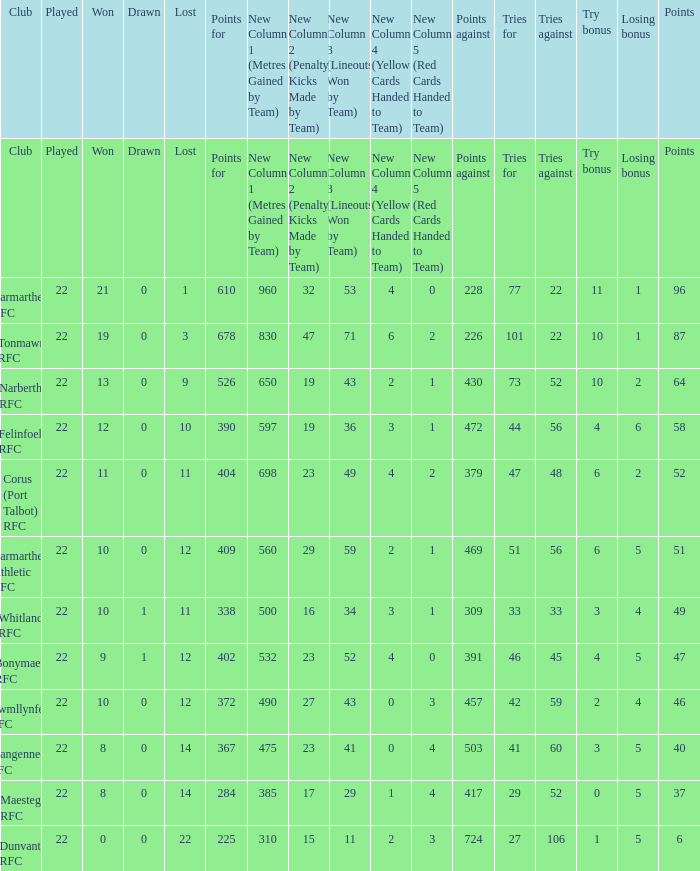Can you parse all the data within this table? {'header': ['Club', 'Played', 'Won', 'Drawn', 'Lost', 'Points for', 'New Column 1 (Metres Gained by Team)', 'New Column 2 (Penalty Kicks Made by Team)', 'New Column 3 (Lineouts Won by Team)', 'New Column 4 (Yellow Cards Handed to Team)', 'New Column 5 (Red Cards Handed to Team)', 'Points against', 'Tries for', 'Tries against', 'Try bonus', 'Losing bonus', 'Points'], 'rows': [['Club', 'Played', 'Won', 'Drawn', 'Lost', 'Points for', 'New Column 1 (Metres Gained by Team)', 'New Column 2 (Penalty Kicks Made by Team)', 'New Column 3 (Lineouts Won by Team)', 'New Column 4 (Yellow Cards Handed to Team)', 'New Column 5 (Red Cards Handed to Team)', 'Points against', 'Tries for', 'Tries against', 'Try bonus', 'Losing bonus', 'Points'], ['Carmarthen RFC', '22', '21', '0', '1', '610', '960', '32', '53', '4', '0', '228', '77', '22', '11', '1', '96'], ['Tonmawr RFC', '22', '19', '0', '3', '678', '830', '47', '71', '6', '2', '226', '101', '22', '10', '1', '87'], ['Narberth RFC', '22', '13', '0', '9', '526', '650', '19', '43', '2', '1', '430', '73', '52', '10', '2', '64'], ['Felinfoel RFC', '22', '12', '0', '10', '390', '597', '19', '36', '3', '1', '472', '44', '56', '4', '6', '58'], ['Corus (Port Talbot) RFC', '22', '11', '0', '11', '404', '698', '23', '49', '4', '2', '379', '47', '48', '6', '2', '52'], ['Carmarthen Athletic RFC', '22', '10', '0', '12', '409', '560', '29', '59', '2', '1', '469', '51', '56', '6', '5', '51'], ['Whitland RFC', '22', '10', '1', '11', '338', '500', '16', '34', '3', '1', '309', '33', '33', '3', '4', '49'], ['Bonymaen RFC', '22', '9', '1', '12', '402', '532', '23', '52', '4', '0', '391', '46', '45', '4', '5', '47'], ['Cwmllynfell RFC', '22', '10', '0', '12', '372', '490', '27', '43', '0', '3', '457', '42', '59', '2', '4', '46'], ['Llangennech RFC', '22', '8', '0', '14', '367', '475', '23', '41', '0', '4', '503', '41', '60', '3', '5', '40'], ['Maesteg RFC', '22', '8', '0', '14', '284', '385', '17', '29', '1', '4', '417', '29', '52', '0', '5', '37'], ['Dunvant RFC', '22', '0', '0', '22', '225', '310', '15', '11', '2', '3', '724', '27', '106', '1', '5', '6']]} Name the try bonus of points against at 430 10.0. 